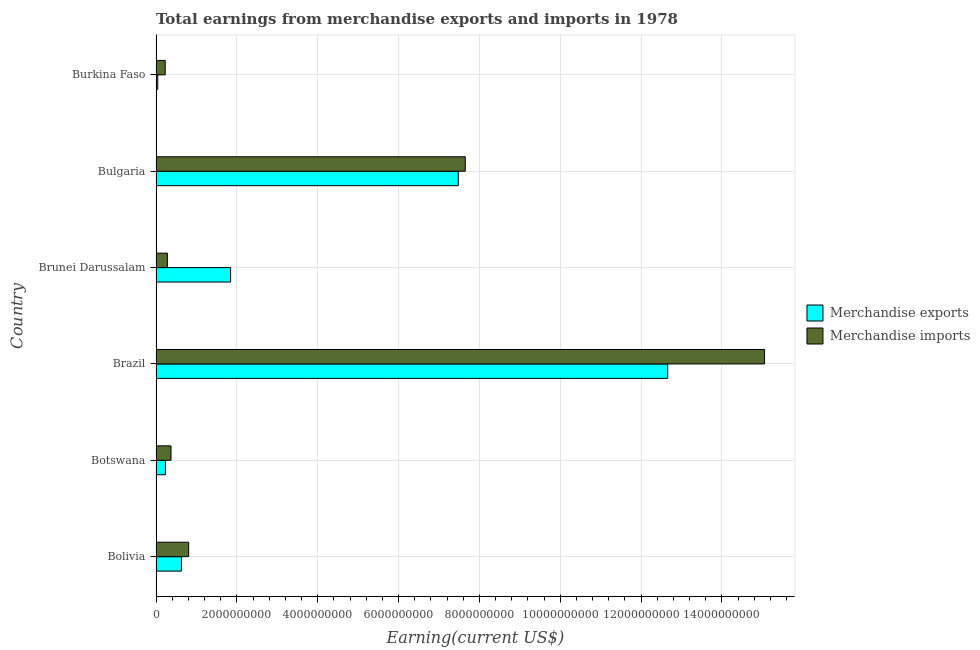How many different coloured bars are there?
Keep it short and to the point. 2. Are the number of bars per tick equal to the number of legend labels?
Offer a very short reply. Yes. Are the number of bars on each tick of the Y-axis equal?
Your answer should be very brief. Yes. What is the label of the 6th group of bars from the top?
Provide a succinct answer. Bolivia. What is the earnings from merchandise imports in Brazil?
Offer a very short reply. 1.51e+1. Across all countries, what is the maximum earnings from merchandise imports?
Offer a very short reply. 1.51e+1. Across all countries, what is the minimum earnings from merchandise exports?
Your response must be concise. 4.27e+07. In which country was the earnings from merchandise exports minimum?
Give a very brief answer. Burkina Faso. What is the total earnings from merchandise exports in the graph?
Offer a terse response. 2.29e+1. What is the difference between the earnings from merchandise exports in Brunei Darussalam and that in Bulgaria?
Your answer should be very brief. -5.63e+09. What is the difference between the earnings from merchandise imports in Brazil and the earnings from merchandise exports in Burkina Faso?
Provide a short and direct response. 1.50e+1. What is the average earnings from merchandise imports per country?
Offer a very short reply. 4.07e+09. What is the difference between the earnings from merchandise imports and earnings from merchandise exports in Bulgaria?
Provide a short and direct response. 1.73e+08. In how many countries, is the earnings from merchandise imports greater than 12400000000 US$?
Provide a short and direct response. 1. What is the ratio of the earnings from merchandise exports in Bolivia to that in Bulgaria?
Give a very brief answer. 0.08. Is the difference between the earnings from merchandise exports in Botswana and Bulgaria greater than the difference between the earnings from merchandise imports in Botswana and Bulgaria?
Your answer should be very brief. Yes. What is the difference between the highest and the second highest earnings from merchandise exports?
Your answer should be very brief. 5.18e+09. What is the difference between the highest and the lowest earnings from merchandise imports?
Your answer should be compact. 1.48e+1. How many bars are there?
Keep it short and to the point. 12. Does the graph contain grids?
Offer a terse response. Yes. Where does the legend appear in the graph?
Offer a terse response. Center right. How many legend labels are there?
Provide a short and direct response. 2. How are the legend labels stacked?
Offer a very short reply. Vertical. What is the title of the graph?
Your answer should be compact. Total earnings from merchandise exports and imports in 1978. Does "Net National savings" appear as one of the legend labels in the graph?
Give a very brief answer. No. What is the label or title of the X-axis?
Your answer should be very brief. Earning(current US$). What is the Earning(current US$) in Merchandise exports in Bolivia?
Your answer should be very brief. 6.29e+08. What is the Earning(current US$) in Merchandise imports in Bolivia?
Your answer should be compact. 8.08e+08. What is the Earning(current US$) of Merchandise exports in Botswana?
Provide a succinct answer. 2.33e+08. What is the Earning(current US$) in Merchandise imports in Botswana?
Keep it short and to the point. 3.71e+08. What is the Earning(current US$) in Merchandise exports in Brazil?
Keep it short and to the point. 1.27e+1. What is the Earning(current US$) in Merchandise imports in Brazil?
Offer a terse response. 1.51e+1. What is the Earning(current US$) in Merchandise exports in Brunei Darussalam?
Your answer should be very brief. 1.84e+09. What is the Earning(current US$) in Merchandise imports in Brunei Darussalam?
Your response must be concise. 2.81e+08. What is the Earning(current US$) in Merchandise exports in Bulgaria?
Offer a very short reply. 7.48e+09. What is the Earning(current US$) in Merchandise imports in Bulgaria?
Make the answer very short. 7.65e+09. What is the Earning(current US$) in Merchandise exports in Burkina Faso?
Keep it short and to the point. 4.27e+07. What is the Earning(current US$) in Merchandise imports in Burkina Faso?
Give a very brief answer. 2.27e+08. Across all countries, what is the maximum Earning(current US$) in Merchandise exports?
Your answer should be very brief. 1.27e+1. Across all countries, what is the maximum Earning(current US$) in Merchandise imports?
Keep it short and to the point. 1.51e+1. Across all countries, what is the minimum Earning(current US$) of Merchandise exports?
Offer a terse response. 4.27e+07. Across all countries, what is the minimum Earning(current US$) in Merchandise imports?
Provide a short and direct response. 2.27e+08. What is the total Earning(current US$) of Merchandise exports in the graph?
Give a very brief answer. 2.29e+1. What is the total Earning(current US$) in Merchandise imports in the graph?
Offer a terse response. 2.44e+1. What is the difference between the Earning(current US$) in Merchandise exports in Bolivia and that in Botswana?
Provide a succinct answer. 3.96e+08. What is the difference between the Earning(current US$) in Merchandise imports in Bolivia and that in Botswana?
Your answer should be compact. 4.37e+08. What is the difference between the Earning(current US$) of Merchandise exports in Bolivia and that in Brazil?
Keep it short and to the point. -1.20e+1. What is the difference between the Earning(current US$) of Merchandise imports in Bolivia and that in Brazil?
Your answer should be very brief. -1.42e+1. What is the difference between the Earning(current US$) of Merchandise exports in Bolivia and that in Brunei Darussalam?
Keep it short and to the point. -1.22e+09. What is the difference between the Earning(current US$) of Merchandise imports in Bolivia and that in Brunei Darussalam?
Your answer should be compact. 5.27e+08. What is the difference between the Earning(current US$) of Merchandise exports in Bolivia and that in Bulgaria?
Provide a succinct answer. -6.85e+09. What is the difference between the Earning(current US$) in Merchandise imports in Bolivia and that in Bulgaria?
Offer a very short reply. -6.84e+09. What is the difference between the Earning(current US$) of Merchandise exports in Bolivia and that in Burkina Faso?
Offer a terse response. 5.86e+08. What is the difference between the Earning(current US$) in Merchandise imports in Bolivia and that in Burkina Faso?
Keep it short and to the point. 5.80e+08. What is the difference between the Earning(current US$) of Merchandise exports in Botswana and that in Brazil?
Offer a terse response. -1.24e+1. What is the difference between the Earning(current US$) in Merchandise imports in Botswana and that in Brazil?
Provide a short and direct response. -1.47e+1. What is the difference between the Earning(current US$) of Merchandise exports in Botswana and that in Brunei Darussalam?
Offer a very short reply. -1.61e+09. What is the difference between the Earning(current US$) in Merchandise imports in Botswana and that in Brunei Darussalam?
Your response must be concise. 8.98e+07. What is the difference between the Earning(current US$) of Merchandise exports in Botswana and that in Bulgaria?
Provide a succinct answer. -7.25e+09. What is the difference between the Earning(current US$) in Merchandise imports in Botswana and that in Bulgaria?
Keep it short and to the point. -7.28e+09. What is the difference between the Earning(current US$) in Merchandise exports in Botswana and that in Burkina Faso?
Your answer should be very brief. 1.90e+08. What is the difference between the Earning(current US$) in Merchandise imports in Botswana and that in Burkina Faso?
Offer a very short reply. 1.43e+08. What is the difference between the Earning(current US$) in Merchandise exports in Brazil and that in Brunei Darussalam?
Offer a very short reply. 1.08e+1. What is the difference between the Earning(current US$) in Merchandise imports in Brazil and that in Brunei Darussalam?
Your response must be concise. 1.48e+1. What is the difference between the Earning(current US$) of Merchandise exports in Brazil and that in Bulgaria?
Offer a very short reply. 5.18e+09. What is the difference between the Earning(current US$) of Merchandise imports in Brazil and that in Bulgaria?
Your answer should be very brief. 7.40e+09. What is the difference between the Earning(current US$) in Merchandise exports in Brazil and that in Burkina Faso?
Give a very brief answer. 1.26e+1. What is the difference between the Earning(current US$) of Merchandise imports in Brazil and that in Burkina Faso?
Offer a terse response. 1.48e+1. What is the difference between the Earning(current US$) in Merchandise exports in Brunei Darussalam and that in Bulgaria?
Make the answer very short. -5.63e+09. What is the difference between the Earning(current US$) of Merchandise imports in Brunei Darussalam and that in Bulgaria?
Provide a short and direct response. -7.37e+09. What is the difference between the Earning(current US$) in Merchandise exports in Brunei Darussalam and that in Burkina Faso?
Ensure brevity in your answer.  1.80e+09. What is the difference between the Earning(current US$) of Merchandise imports in Brunei Darussalam and that in Burkina Faso?
Your answer should be compact. 5.35e+07. What is the difference between the Earning(current US$) in Merchandise exports in Bulgaria and that in Burkina Faso?
Provide a succinct answer. 7.44e+09. What is the difference between the Earning(current US$) of Merchandise imports in Bulgaria and that in Burkina Faso?
Offer a terse response. 7.42e+09. What is the difference between the Earning(current US$) of Merchandise exports in Bolivia and the Earning(current US$) of Merchandise imports in Botswana?
Offer a very short reply. 2.58e+08. What is the difference between the Earning(current US$) of Merchandise exports in Bolivia and the Earning(current US$) of Merchandise imports in Brazil?
Provide a short and direct response. -1.44e+1. What is the difference between the Earning(current US$) of Merchandise exports in Bolivia and the Earning(current US$) of Merchandise imports in Brunei Darussalam?
Provide a short and direct response. 3.48e+08. What is the difference between the Earning(current US$) in Merchandise exports in Bolivia and the Earning(current US$) in Merchandise imports in Bulgaria?
Your answer should be very brief. -7.02e+09. What is the difference between the Earning(current US$) in Merchandise exports in Bolivia and the Earning(current US$) in Merchandise imports in Burkina Faso?
Offer a terse response. 4.01e+08. What is the difference between the Earning(current US$) of Merchandise exports in Botswana and the Earning(current US$) of Merchandise imports in Brazil?
Your response must be concise. -1.48e+1. What is the difference between the Earning(current US$) of Merchandise exports in Botswana and the Earning(current US$) of Merchandise imports in Brunei Darussalam?
Keep it short and to the point. -4.83e+07. What is the difference between the Earning(current US$) of Merchandise exports in Botswana and the Earning(current US$) of Merchandise imports in Bulgaria?
Offer a terse response. -7.42e+09. What is the difference between the Earning(current US$) of Merchandise exports in Botswana and the Earning(current US$) of Merchandise imports in Burkina Faso?
Provide a succinct answer. 5.18e+06. What is the difference between the Earning(current US$) of Merchandise exports in Brazil and the Earning(current US$) of Merchandise imports in Brunei Darussalam?
Offer a terse response. 1.24e+1. What is the difference between the Earning(current US$) in Merchandise exports in Brazil and the Earning(current US$) in Merchandise imports in Bulgaria?
Provide a short and direct response. 5.01e+09. What is the difference between the Earning(current US$) in Merchandise exports in Brazil and the Earning(current US$) in Merchandise imports in Burkina Faso?
Offer a very short reply. 1.24e+1. What is the difference between the Earning(current US$) in Merchandise exports in Brunei Darussalam and the Earning(current US$) in Merchandise imports in Bulgaria?
Offer a very short reply. -5.81e+09. What is the difference between the Earning(current US$) of Merchandise exports in Brunei Darussalam and the Earning(current US$) of Merchandise imports in Burkina Faso?
Offer a very short reply. 1.62e+09. What is the difference between the Earning(current US$) of Merchandise exports in Bulgaria and the Earning(current US$) of Merchandise imports in Burkina Faso?
Offer a very short reply. 7.25e+09. What is the average Earning(current US$) in Merchandise exports per country?
Your response must be concise. 3.81e+09. What is the average Earning(current US$) of Merchandise imports per country?
Make the answer very short. 4.07e+09. What is the difference between the Earning(current US$) of Merchandise exports and Earning(current US$) of Merchandise imports in Bolivia?
Ensure brevity in your answer.  -1.79e+08. What is the difference between the Earning(current US$) of Merchandise exports and Earning(current US$) of Merchandise imports in Botswana?
Keep it short and to the point. -1.38e+08. What is the difference between the Earning(current US$) of Merchandise exports and Earning(current US$) of Merchandise imports in Brazil?
Offer a very short reply. -2.40e+09. What is the difference between the Earning(current US$) of Merchandise exports and Earning(current US$) of Merchandise imports in Brunei Darussalam?
Provide a short and direct response. 1.56e+09. What is the difference between the Earning(current US$) of Merchandise exports and Earning(current US$) of Merchandise imports in Bulgaria?
Offer a very short reply. -1.73e+08. What is the difference between the Earning(current US$) in Merchandise exports and Earning(current US$) in Merchandise imports in Burkina Faso?
Keep it short and to the point. -1.85e+08. What is the ratio of the Earning(current US$) in Merchandise exports in Bolivia to that in Botswana?
Provide a succinct answer. 2.7. What is the ratio of the Earning(current US$) of Merchandise imports in Bolivia to that in Botswana?
Your answer should be compact. 2.18. What is the ratio of the Earning(current US$) of Merchandise exports in Bolivia to that in Brazil?
Offer a terse response. 0.05. What is the ratio of the Earning(current US$) in Merchandise imports in Bolivia to that in Brazil?
Your answer should be very brief. 0.05. What is the ratio of the Earning(current US$) of Merchandise exports in Bolivia to that in Brunei Darussalam?
Provide a short and direct response. 0.34. What is the ratio of the Earning(current US$) in Merchandise imports in Bolivia to that in Brunei Darussalam?
Make the answer very short. 2.87. What is the ratio of the Earning(current US$) in Merchandise exports in Bolivia to that in Bulgaria?
Keep it short and to the point. 0.08. What is the ratio of the Earning(current US$) of Merchandise imports in Bolivia to that in Bulgaria?
Your response must be concise. 0.11. What is the ratio of the Earning(current US$) of Merchandise exports in Bolivia to that in Burkina Faso?
Your answer should be compact. 14.72. What is the ratio of the Earning(current US$) in Merchandise imports in Bolivia to that in Burkina Faso?
Give a very brief answer. 3.55. What is the ratio of the Earning(current US$) in Merchandise exports in Botswana to that in Brazil?
Provide a short and direct response. 0.02. What is the ratio of the Earning(current US$) of Merchandise imports in Botswana to that in Brazil?
Keep it short and to the point. 0.02. What is the ratio of the Earning(current US$) in Merchandise exports in Botswana to that in Brunei Darussalam?
Your answer should be compact. 0.13. What is the ratio of the Earning(current US$) in Merchandise imports in Botswana to that in Brunei Darussalam?
Offer a very short reply. 1.32. What is the ratio of the Earning(current US$) of Merchandise exports in Botswana to that in Bulgaria?
Your answer should be very brief. 0.03. What is the ratio of the Earning(current US$) of Merchandise imports in Botswana to that in Bulgaria?
Your answer should be very brief. 0.05. What is the ratio of the Earning(current US$) of Merchandise exports in Botswana to that in Burkina Faso?
Keep it short and to the point. 5.45. What is the ratio of the Earning(current US$) of Merchandise imports in Botswana to that in Burkina Faso?
Keep it short and to the point. 1.63. What is the ratio of the Earning(current US$) of Merchandise exports in Brazil to that in Brunei Darussalam?
Your answer should be compact. 6.86. What is the ratio of the Earning(current US$) in Merchandise imports in Brazil to that in Brunei Darussalam?
Offer a terse response. 53.57. What is the ratio of the Earning(current US$) of Merchandise exports in Brazil to that in Bulgaria?
Make the answer very short. 1.69. What is the ratio of the Earning(current US$) of Merchandise imports in Brazil to that in Bulgaria?
Your answer should be very brief. 1.97. What is the ratio of the Earning(current US$) of Merchandise exports in Brazil to that in Burkina Faso?
Your response must be concise. 296.43. What is the ratio of the Earning(current US$) of Merchandise imports in Brazil to that in Burkina Faso?
Provide a short and direct response. 66.18. What is the ratio of the Earning(current US$) in Merchandise exports in Brunei Darussalam to that in Bulgaria?
Keep it short and to the point. 0.25. What is the ratio of the Earning(current US$) in Merchandise imports in Brunei Darussalam to that in Bulgaria?
Give a very brief answer. 0.04. What is the ratio of the Earning(current US$) in Merchandise exports in Brunei Darussalam to that in Burkina Faso?
Provide a short and direct response. 43.2. What is the ratio of the Earning(current US$) of Merchandise imports in Brunei Darussalam to that in Burkina Faso?
Offer a very short reply. 1.24. What is the ratio of the Earning(current US$) of Merchandise exports in Bulgaria to that in Burkina Faso?
Offer a very short reply. 175.11. What is the ratio of the Earning(current US$) of Merchandise imports in Bulgaria to that in Burkina Faso?
Make the answer very short. 33.63. What is the difference between the highest and the second highest Earning(current US$) of Merchandise exports?
Give a very brief answer. 5.18e+09. What is the difference between the highest and the second highest Earning(current US$) of Merchandise imports?
Your answer should be very brief. 7.40e+09. What is the difference between the highest and the lowest Earning(current US$) of Merchandise exports?
Ensure brevity in your answer.  1.26e+1. What is the difference between the highest and the lowest Earning(current US$) in Merchandise imports?
Keep it short and to the point. 1.48e+1. 